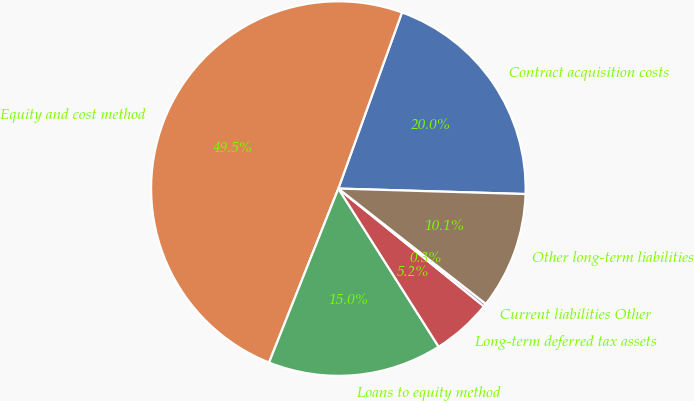Convert chart. <chart><loc_0><loc_0><loc_500><loc_500><pie_chart><fcel>Contract acquisition costs<fcel>Equity and cost method<fcel>Loans to equity method<fcel>Long-term deferred tax assets<fcel>Current liabilities Other<fcel>Other long-term liabilities<nl><fcel>19.95%<fcel>49.48%<fcel>15.03%<fcel>5.18%<fcel>0.26%<fcel>10.1%<nl></chart> 